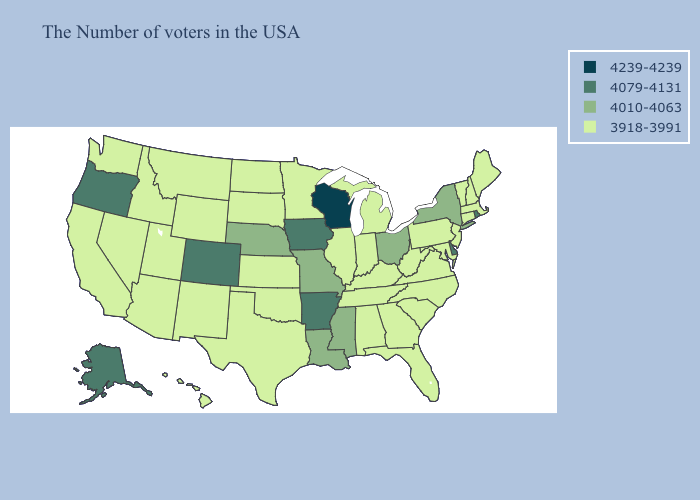Name the states that have a value in the range 3918-3991?
Write a very short answer. Maine, Massachusetts, New Hampshire, Vermont, Connecticut, New Jersey, Maryland, Pennsylvania, Virginia, North Carolina, South Carolina, West Virginia, Florida, Georgia, Michigan, Kentucky, Indiana, Alabama, Tennessee, Illinois, Minnesota, Kansas, Oklahoma, Texas, South Dakota, North Dakota, Wyoming, New Mexico, Utah, Montana, Arizona, Idaho, Nevada, California, Washington, Hawaii. Among the states that border Louisiana , does Texas have the highest value?
Write a very short answer. No. What is the highest value in states that border Pennsylvania?
Quick response, please. 4079-4131. Does the map have missing data?
Give a very brief answer. No. What is the highest value in the South ?
Write a very short answer. 4079-4131. Which states have the highest value in the USA?
Quick response, please. Wisconsin. Does Delaware have the lowest value in the South?
Answer briefly. No. What is the value of Idaho?
Write a very short answer. 3918-3991. Which states have the lowest value in the USA?
Short answer required. Maine, Massachusetts, New Hampshire, Vermont, Connecticut, New Jersey, Maryland, Pennsylvania, Virginia, North Carolina, South Carolina, West Virginia, Florida, Georgia, Michigan, Kentucky, Indiana, Alabama, Tennessee, Illinois, Minnesota, Kansas, Oklahoma, Texas, South Dakota, North Dakota, Wyoming, New Mexico, Utah, Montana, Arizona, Idaho, Nevada, California, Washington, Hawaii. What is the highest value in the Northeast ?
Concise answer only. 4079-4131. Does Tennessee have the lowest value in the South?
Short answer required. Yes. Does Wisconsin have the highest value in the USA?
Concise answer only. Yes. What is the value of Mississippi?
Give a very brief answer. 4010-4063. Name the states that have a value in the range 4010-4063?
Quick response, please. New York, Ohio, Mississippi, Louisiana, Missouri, Nebraska. What is the value of California?
Answer briefly. 3918-3991. 